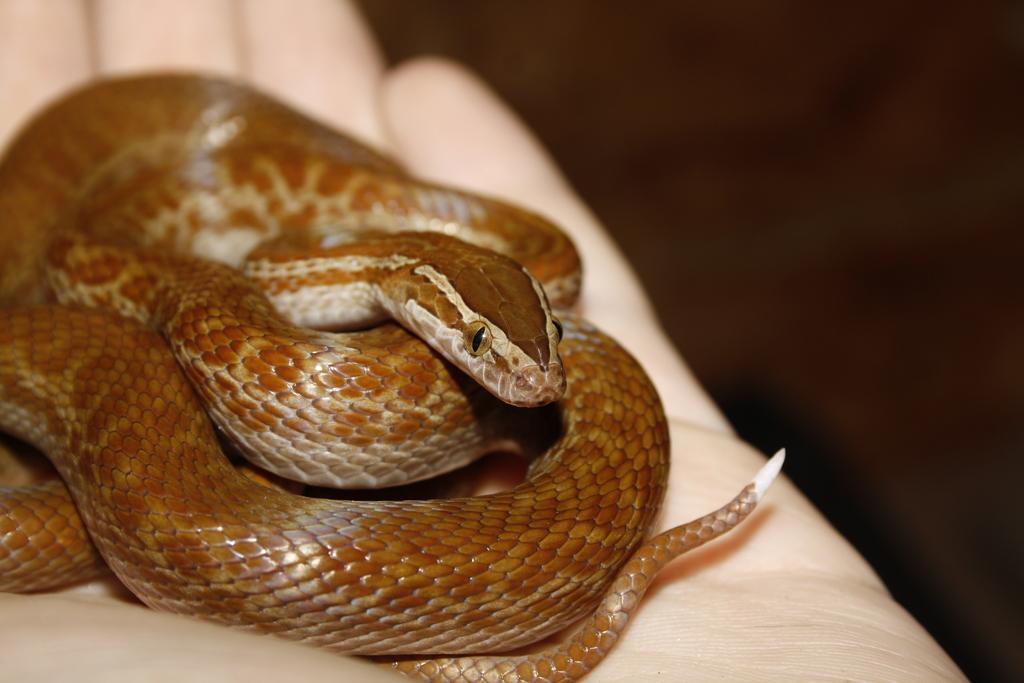Describe this image in one or two sentences. As we can see in the image there is a white color cloth and a snake. 